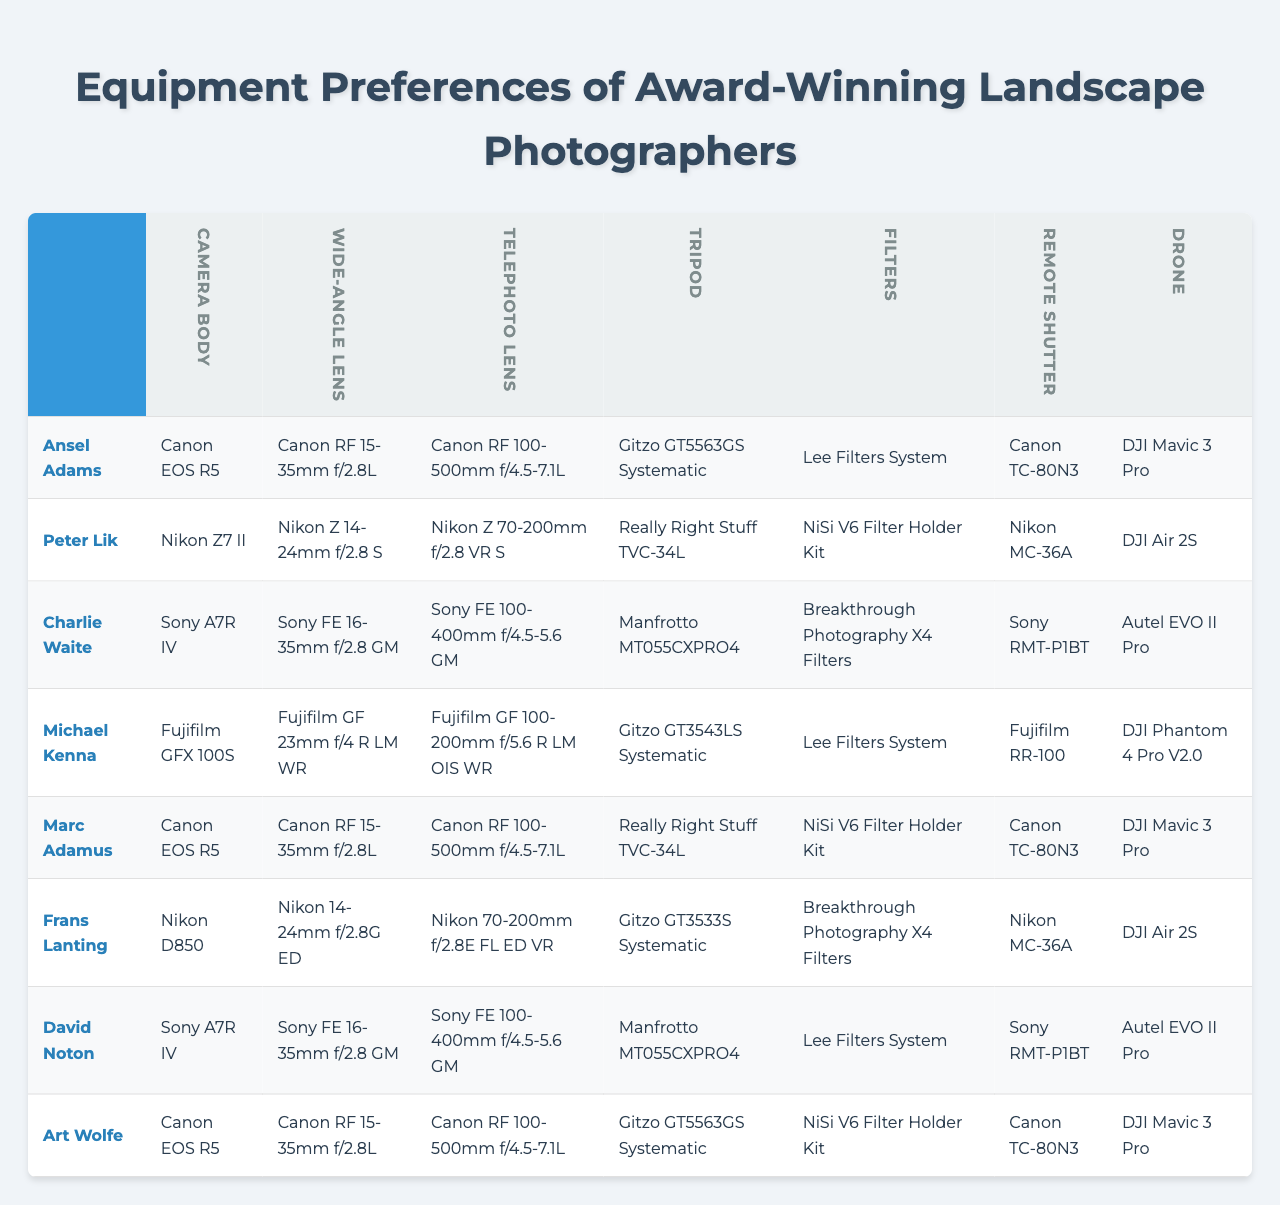What camera body does Ansel Adams use? From the first row of the table under the "Camera Body" category, Ansel Adams is listed with "Canon EOS R5."
Answer: Canon EOS R5 Which photographer uses the Nikon Z 70-200mm f/2.8 VR S telephoto lens? Looking at the third row under the "Telephoto Lens" category, the Nikon Z 70-200mm f/2.8 VR S is associated with the photographer Charlie Waite.
Answer: Charlie Waite How many photographers use the Canon RF 15-35mm f/2.8L wide-angle lens? By counting the occurrences of "Canon RF 15-35mm f/2.8L" in the second row, we see it appears four times, indicating four photographers.
Answer: 4 Is there a common tripod used among the photographers? Observing the fourth column under "Tripod," "Gitzo GT5563GS Systematic" is used by both Ansel Adams and Art Wolfe, making it a common choice.
Answer: Yes Which lens category has the most diversity in brand among the photographers? Looking at the "Wide-Angle Lens" category, there are four different brands used (Canon, Nikon, Sony, and Fujifilm), compared to others that have less variety.
Answer: Wide-Angle Lens What is the most commonly used drone among the listed photographers? The sixth row under "Drone" shows that "DJI Mavic 3 Pro" is mentioned three times, which indicates it's the most frequently used drone.
Answer: DJI Mavic 3 Pro Does any photographer use the same remote shutter device? In the "Remote Shutter" category, "Canon TC-80N3" is used by three different photographers (Ansel Adams, Marc Adamus, and David Noton), confirming that multiple photographers use the same device.
Answer: Yes What is the relationship between camera body preferences and drone choices for the photographers? Analyzing both rows shows that photographers who prefer Canon bodies (like Ansel Adams and Marc Adamus) also choose the DJI Mavic 3 Pro for drones, indicating a potential brand loyalty.
Answer: Canon users prefer DJI Mavic 3 Pro Are there more filter types or lens types used by the award-winning landscape photographers? If we count the entries under both categories, there are more distinct types of lenses (six) than filters (four), indicating a greater variety in lens choice.
Answer: More lens types What percentage of photographers use a Remote Shutter from Canon? There are eight photographers total, with three using "Canon TC-80N3," so the calculation is (3/8) * 100 = 37.5%.
Answer: 37.5% 